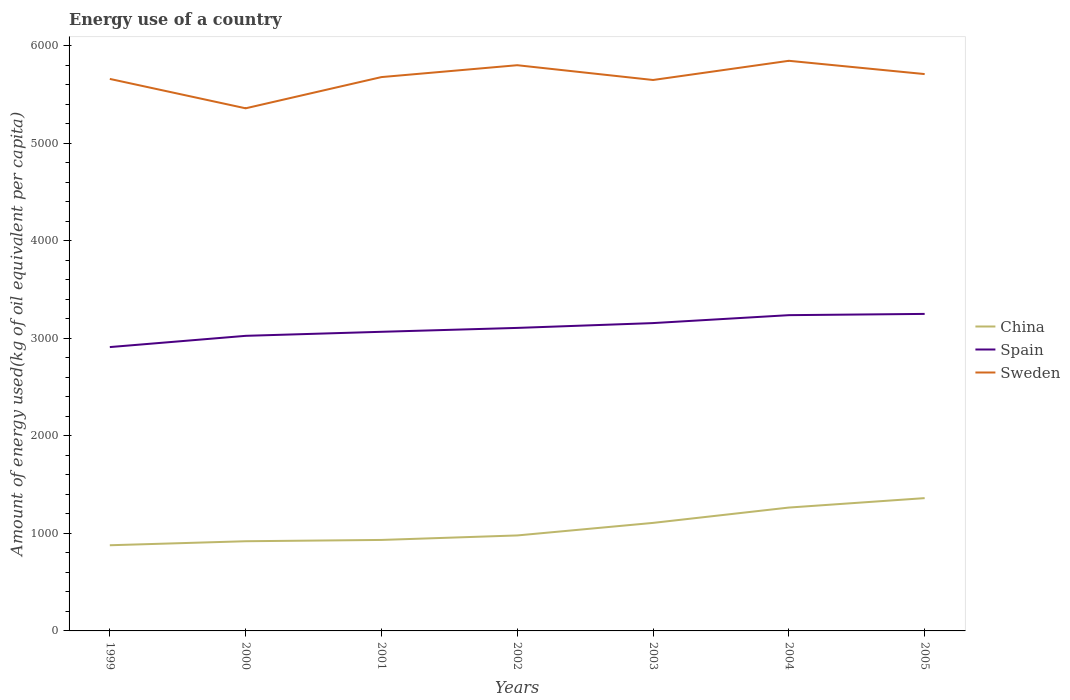How many different coloured lines are there?
Give a very brief answer. 3. Across all years, what is the maximum amount of energy used in in China?
Your answer should be compact. 878.64. What is the total amount of energy used in in Sweden in the graph?
Your answer should be compact. 301.35. What is the difference between the highest and the second highest amount of energy used in in Sweden?
Offer a terse response. 487.2. What is the difference between the highest and the lowest amount of energy used in in Sweden?
Offer a terse response. 4. How many years are there in the graph?
Keep it short and to the point. 7. What is the difference between two consecutive major ticks on the Y-axis?
Provide a short and direct response. 1000. Are the values on the major ticks of Y-axis written in scientific E-notation?
Your answer should be compact. No. How are the legend labels stacked?
Your answer should be compact. Vertical. What is the title of the graph?
Offer a terse response. Energy use of a country. What is the label or title of the X-axis?
Your answer should be very brief. Years. What is the label or title of the Y-axis?
Your answer should be very brief. Amount of energy used(kg of oil equivalent per capita). What is the Amount of energy used(kg of oil equivalent per capita) of China in 1999?
Give a very brief answer. 878.64. What is the Amount of energy used(kg of oil equivalent per capita) of Spain in 1999?
Provide a short and direct response. 2911.18. What is the Amount of energy used(kg of oil equivalent per capita) of Sweden in 1999?
Provide a succinct answer. 5661.49. What is the Amount of energy used(kg of oil equivalent per capita) of China in 2000?
Your response must be concise. 919.78. What is the Amount of energy used(kg of oil equivalent per capita) in Spain in 2000?
Provide a succinct answer. 3026.49. What is the Amount of energy used(kg of oil equivalent per capita) in Sweden in 2000?
Ensure brevity in your answer.  5360.15. What is the Amount of energy used(kg of oil equivalent per capita) of China in 2001?
Your answer should be very brief. 933.13. What is the Amount of energy used(kg of oil equivalent per capita) of Spain in 2001?
Provide a succinct answer. 3067.97. What is the Amount of energy used(kg of oil equivalent per capita) in Sweden in 2001?
Provide a short and direct response. 5680.28. What is the Amount of energy used(kg of oil equivalent per capita) in China in 2002?
Provide a succinct answer. 979.25. What is the Amount of energy used(kg of oil equivalent per capita) in Spain in 2002?
Keep it short and to the point. 3107.87. What is the Amount of energy used(kg of oil equivalent per capita) of Sweden in 2002?
Your response must be concise. 5802.11. What is the Amount of energy used(kg of oil equivalent per capita) in China in 2003?
Provide a succinct answer. 1108.01. What is the Amount of energy used(kg of oil equivalent per capita) in Spain in 2003?
Provide a succinct answer. 3157.23. What is the Amount of energy used(kg of oil equivalent per capita) in Sweden in 2003?
Your answer should be compact. 5650.44. What is the Amount of energy used(kg of oil equivalent per capita) in China in 2004?
Ensure brevity in your answer.  1265.25. What is the Amount of energy used(kg of oil equivalent per capita) in Spain in 2004?
Make the answer very short. 3238.5. What is the Amount of energy used(kg of oil equivalent per capita) of Sweden in 2004?
Ensure brevity in your answer.  5847.34. What is the Amount of energy used(kg of oil equivalent per capita) in China in 2005?
Offer a very short reply. 1362.01. What is the Amount of energy used(kg of oil equivalent per capita) in Spain in 2005?
Give a very brief answer. 3251.4. What is the Amount of energy used(kg of oil equivalent per capita) of Sweden in 2005?
Provide a short and direct response. 5711.13. Across all years, what is the maximum Amount of energy used(kg of oil equivalent per capita) in China?
Your answer should be very brief. 1362.01. Across all years, what is the maximum Amount of energy used(kg of oil equivalent per capita) of Spain?
Offer a terse response. 3251.4. Across all years, what is the maximum Amount of energy used(kg of oil equivalent per capita) in Sweden?
Offer a very short reply. 5847.34. Across all years, what is the minimum Amount of energy used(kg of oil equivalent per capita) of China?
Provide a short and direct response. 878.64. Across all years, what is the minimum Amount of energy used(kg of oil equivalent per capita) in Spain?
Give a very brief answer. 2911.18. Across all years, what is the minimum Amount of energy used(kg of oil equivalent per capita) of Sweden?
Ensure brevity in your answer.  5360.15. What is the total Amount of energy used(kg of oil equivalent per capita) in China in the graph?
Provide a succinct answer. 7446.05. What is the total Amount of energy used(kg of oil equivalent per capita) in Spain in the graph?
Offer a terse response. 2.18e+04. What is the total Amount of energy used(kg of oil equivalent per capita) in Sweden in the graph?
Your answer should be compact. 3.97e+04. What is the difference between the Amount of energy used(kg of oil equivalent per capita) in China in 1999 and that in 2000?
Ensure brevity in your answer.  -41.14. What is the difference between the Amount of energy used(kg of oil equivalent per capita) of Spain in 1999 and that in 2000?
Your response must be concise. -115.31. What is the difference between the Amount of energy used(kg of oil equivalent per capita) of Sweden in 1999 and that in 2000?
Make the answer very short. 301.35. What is the difference between the Amount of energy used(kg of oil equivalent per capita) in China in 1999 and that in 2001?
Offer a terse response. -54.49. What is the difference between the Amount of energy used(kg of oil equivalent per capita) in Spain in 1999 and that in 2001?
Make the answer very short. -156.79. What is the difference between the Amount of energy used(kg of oil equivalent per capita) in Sweden in 1999 and that in 2001?
Your answer should be compact. -18.79. What is the difference between the Amount of energy used(kg of oil equivalent per capita) of China in 1999 and that in 2002?
Keep it short and to the point. -100.61. What is the difference between the Amount of energy used(kg of oil equivalent per capita) in Spain in 1999 and that in 2002?
Give a very brief answer. -196.68. What is the difference between the Amount of energy used(kg of oil equivalent per capita) of Sweden in 1999 and that in 2002?
Offer a very short reply. -140.62. What is the difference between the Amount of energy used(kg of oil equivalent per capita) of China in 1999 and that in 2003?
Give a very brief answer. -229.37. What is the difference between the Amount of energy used(kg of oil equivalent per capita) of Spain in 1999 and that in 2003?
Offer a very short reply. -246.04. What is the difference between the Amount of energy used(kg of oil equivalent per capita) of Sweden in 1999 and that in 2003?
Your response must be concise. 11.05. What is the difference between the Amount of energy used(kg of oil equivalent per capita) of China in 1999 and that in 2004?
Provide a succinct answer. -386.61. What is the difference between the Amount of energy used(kg of oil equivalent per capita) of Spain in 1999 and that in 2004?
Keep it short and to the point. -327.32. What is the difference between the Amount of energy used(kg of oil equivalent per capita) in Sweden in 1999 and that in 2004?
Your answer should be compact. -185.85. What is the difference between the Amount of energy used(kg of oil equivalent per capita) of China in 1999 and that in 2005?
Provide a succinct answer. -483.37. What is the difference between the Amount of energy used(kg of oil equivalent per capita) of Spain in 1999 and that in 2005?
Ensure brevity in your answer.  -340.21. What is the difference between the Amount of energy used(kg of oil equivalent per capita) of Sweden in 1999 and that in 2005?
Make the answer very short. -49.64. What is the difference between the Amount of energy used(kg of oil equivalent per capita) in China in 2000 and that in 2001?
Your response must be concise. -13.35. What is the difference between the Amount of energy used(kg of oil equivalent per capita) in Spain in 2000 and that in 2001?
Your answer should be compact. -41.48. What is the difference between the Amount of energy used(kg of oil equivalent per capita) in Sweden in 2000 and that in 2001?
Ensure brevity in your answer.  -320.14. What is the difference between the Amount of energy used(kg of oil equivalent per capita) of China in 2000 and that in 2002?
Make the answer very short. -59.47. What is the difference between the Amount of energy used(kg of oil equivalent per capita) in Spain in 2000 and that in 2002?
Give a very brief answer. -81.38. What is the difference between the Amount of energy used(kg of oil equivalent per capita) of Sweden in 2000 and that in 2002?
Give a very brief answer. -441.96. What is the difference between the Amount of energy used(kg of oil equivalent per capita) in China in 2000 and that in 2003?
Offer a terse response. -188.23. What is the difference between the Amount of energy used(kg of oil equivalent per capita) of Spain in 2000 and that in 2003?
Provide a short and direct response. -130.74. What is the difference between the Amount of energy used(kg of oil equivalent per capita) in Sweden in 2000 and that in 2003?
Provide a short and direct response. -290.29. What is the difference between the Amount of energy used(kg of oil equivalent per capita) of China in 2000 and that in 2004?
Your answer should be compact. -345.47. What is the difference between the Amount of energy used(kg of oil equivalent per capita) in Spain in 2000 and that in 2004?
Keep it short and to the point. -212.01. What is the difference between the Amount of energy used(kg of oil equivalent per capita) of Sweden in 2000 and that in 2004?
Ensure brevity in your answer.  -487.2. What is the difference between the Amount of energy used(kg of oil equivalent per capita) of China in 2000 and that in 2005?
Your answer should be very brief. -442.23. What is the difference between the Amount of energy used(kg of oil equivalent per capita) in Spain in 2000 and that in 2005?
Make the answer very short. -224.91. What is the difference between the Amount of energy used(kg of oil equivalent per capita) in Sweden in 2000 and that in 2005?
Your response must be concise. -350.98. What is the difference between the Amount of energy used(kg of oil equivalent per capita) in China in 2001 and that in 2002?
Your answer should be compact. -46.12. What is the difference between the Amount of energy used(kg of oil equivalent per capita) of Spain in 2001 and that in 2002?
Offer a terse response. -39.9. What is the difference between the Amount of energy used(kg of oil equivalent per capita) of Sweden in 2001 and that in 2002?
Your answer should be compact. -121.83. What is the difference between the Amount of energy used(kg of oil equivalent per capita) of China in 2001 and that in 2003?
Keep it short and to the point. -174.88. What is the difference between the Amount of energy used(kg of oil equivalent per capita) in Spain in 2001 and that in 2003?
Keep it short and to the point. -89.25. What is the difference between the Amount of energy used(kg of oil equivalent per capita) of Sweden in 2001 and that in 2003?
Provide a succinct answer. 29.84. What is the difference between the Amount of energy used(kg of oil equivalent per capita) in China in 2001 and that in 2004?
Offer a very short reply. -332.12. What is the difference between the Amount of energy used(kg of oil equivalent per capita) in Spain in 2001 and that in 2004?
Give a very brief answer. -170.53. What is the difference between the Amount of energy used(kg of oil equivalent per capita) of Sweden in 2001 and that in 2004?
Provide a short and direct response. -167.06. What is the difference between the Amount of energy used(kg of oil equivalent per capita) in China in 2001 and that in 2005?
Offer a very short reply. -428.88. What is the difference between the Amount of energy used(kg of oil equivalent per capita) in Spain in 2001 and that in 2005?
Ensure brevity in your answer.  -183.42. What is the difference between the Amount of energy used(kg of oil equivalent per capita) in Sweden in 2001 and that in 2005?
Your response must be concise. -30.85. What is the difference between the Amount of energy used(kg of oil equivalent per capita) in China in 2002 and that in 2003?
Ensure brevity in your answer.  -128.76. What is the difference between the Amount of energy used(kg of oil equivalent per capita) of Spain in 2002 and that in 2003?
Make the answer very short. -49.36. What is the difference between the Amount of energy used(kg of oil equivalent per capita) in Sweden in 2002 and that in 2003?
Give a very brief answer. 151.67. What is the difference between the Amount of energy used(kg of oil equivalent per capita) in China in 2002 and that in 2004?
Provide a short and direct response. -286. What is the difference between the Amount of energy used(kg of oil equivalent per capita) of Spain in 2002 and that in 2004?
Provide a succinct answer. -130.64. What is the difference between the Amount of energy used(kg of oil equivalent per capita) of Sweden in 2002 and that in 2004?
Offer a very short reply. -45.23. What is the difference between the Amount of energy used(kg of oil equivalent per capita) of China in 2002 and that in 2005?
Provide a short and direct response. -382.76. What is the difference between the Amount of energy used(kg of oil equivalent per capita) in Spain in 2002 and that in 2005?
Keep it short and to the point. -143.53. What is the difference between the Amount of energy used(kg of oil equivalent per capita) of Sweden in 2002 and that in 2005?
Ensure brevity in your answer.  90.98. What is the difference between the Amount of energy used(kg of oil equivalent per capita) in China in 2003 and that in 2004?
Provide a succinct answer. -157.24. What is the difference between the Amount of energy used(kg of oil equivalent per capita) in Spain in 2003 and that in 2004?
Offer a very short reply. -81.28. What is the difference between the Amount of energy used(kg of oil equivalent per capita) of Sweden in 2003 and that in 2004?
Provide a short and direct response. -196.91. What is the difference between the Amount of energy used(kg of oil equivalent per capita) in China in 2003 and that in 2005?
Provide a short and direct response. -254. What is the difference between the Amount of energy used(kg of oil equivalent per capita) of Spain in 2003 and that in 2005?
Make the answer very short. -94.17. What is the difference between the Amount of energy used(kg of oil equivalent per capita) in Sweden in 2003 and that in 2005?
Offer a very short reply. -60.69. What is the difference between the Amount of energy used(kg of oil equivalent per capita) of China in 2004 and that in 2005?
Provide a short and direct response. -96.76. What is the difference between the Amount of energy used(kg of oil equivalent per capita) in Spain in 2004 and that in 2005?
Your answer should be compact. -12.89. What is the difference between the Amount of energy used(kg of oil equivalent per capita) in Sweden in 2004 and that in 2005?
Provide a succinct answer. 136.22. What is the difference between the Amount of energy used(kg of oil equivalent per capita) of China in 1999 and the Amount of energy used(kg of oil equivalent per capita) of Spain in 2000?
Offer a very short reply. -2147.85. What is the difference between the Amount of energy used(kg of oil equivalent per capita) in China in 1999 and the Amount of energy used(kg of oil equivalent per capita) in Sweden in 2000?
Provide a succinct answer. -4481.51. What is the difference between the Amount of energy used(kg of oil equivalent per capita) in Spain in 1999 and the Amount of energy used(kg of oil equivalent per capita) in Sweden in 2000?
Ensure brevity in your answer.  -2448.96. What is the difference between the Amount of energy used(kg of oil equivalent per capita) in China in 1999 and the Amount of energy used(kg of oil equivalent per capita) in Spain in 2001?
Your answer should be very brief. -2189.33. What is the difference between the Amount of energy used(kg of oil equivalent per capita) in China in 1999 and the Amount of energy used(kg of oil equivalent per capita) in Sweden in 2001?
Give a very brief answer. -4801.64. What is the difference between the Amount of energy used(kg of oil equivalent per capita) of Spain in 1999 and the Amount of energy used(kg of oil equivalent per capita) of Sweden in 2001?
Your answer should be very brief. -2769.1. What is the difference between the Amount of energy used(kg of oil equivalent per capita) of China in 1999 and the Amount of energy used(kg of oil equivalent per capita) of Spain in 2002?
Make the answer very short. -2229.23. What is the difference between the Amount of energy used(kg of oil equivalent per capita) in China in 1999 and the Amount of energy used(kg of oil equivalent per capita) in Sweden in 2002?
Make the answer very short. -4923.47. What is the difference between the Amount of energy used(kg of oil equivalent per capita) of Spain in 1999 and the Amount of energy used(kg of oil equivalent per capita) of Sweden in 2002?
Provide a short and direct response. -2890.93. What is the difference between the Amount of energy used(kg of oil equivalent per capita) of China in 1999 and the Amount of energy used(kg of oil equivalent per capita) of Spain in 2003?
Give a very brief answer. -2278.59. What is the difference between the Amount of energy used(kg of oil equivalent per capita) of China in 1999 and the Amount of energy used(kg of oil equivalent per capita) of Sweden in 2003?
Keep it short and to the point. -4771.8. What is the difference between the Amount of energy used(kg of oil equivalent per capita) of Spain in 1999 and the Amount of energy used(kg of oil equivalent per capita) of Sweden in 2003?
Ensure brevity in your answer.  -2739.25. What is the difference between the Amount of energy used(kg of oil equivalent per capita) in China in 1999 and the Amount of energy used(kg of oil equivalent per capita) in Spain in 2004?
Offer a very short reply. -2359.86. What is the difference between the Amount of energy used(kg of oil equivalent per capita) of China in 1999 and the Amount of energy used(kg of oil equivalent per capita) of Sweden in 2004?
Give a very brief answer. -4968.71. What is the difference between the Amount of energy used(kg of oil equivalent per capita) of Spain in 1999 and the Amount of energy used(kg of oil equivalent per capita) of Sweden in 2004?
Provide a succinct answer. -2936.16. What is the difference between the Amount of energy used(kg of oil equivalent per capita) in China in 1999 and the Amount of energy used(kg of oil equivalent per capita) in Spain in 2005?
Make the answer very short. -2372.76. What is the difference between the Amount of energy used(kg of oil equivalent per capita) in China in 1999 and the Amount of energy used(kg of oil equivalent per capita) in Sweden in 2005?
Ensure brevity in your answer.  -4832.49. What is the difference between the Amount of energy used(kg of oil equivalent per capita) of Spain in 1999 and the Amount of energy used(kg of oil equivalent per capita) of Sweden in 2005?
Provide a succinct answer. -2799.94. What is the difference between the Amount of energy used(kg of oil equivalent per capita) of China in 2000 and the Amount of energy used(kg of oil equivalent per capita) of Spain in 2001?
Your response must be concise. -2148.19. What is the difference between the Amount of energy used(kg of oil equivalent per capita) of China in 2000 and the Amount of energy used(kg of oil equivalent per capita) of Sweden in 2001?
Give a very brief answer. -4760.5. What is the difference between the Amount of energy used(kg of oil equivalent per capita) in Spain in 2000 and the Amount of energy used(kg of oil equivalent per capita) in Sweden in 2001?
Give a very brief answer. -2653.79. What is the difference between the Amount of energy used(kg of oil equivalent per capita) of China in 2000 and the Amount of energy used(kg of oil equivalent per capita) of Spain in 2002?
Provide a succinct answer. -2188.09. What is the difference between the Amount of energy used(kg of oil equivalent per capita) of China in 2000 and the Amount of energy used(kg of oil equivalent per capita) of Sweden in 2002?
Your response must be concise. -4882.33. What is the difference between the Amount of energy used(kg of oil equivalent per capita) in Spain in 2000 and the Amount of energy used(kg of oil equivalent per capita) in Sweden in 2002?
Offer a very short reply. -2775.62. What is the difference between the Amount of energy used(kg of oil equivalent per capita) in China in 2000 and the Amount of energy used(kg of oil equivalent per capita) in Spain in 2003?
Provide a short and direct response. -2237.45. What is the difference between the Amount of energy used(kg of oil equivalent per capita) in China in 2000 and the Amount of energy used(kg of oil equivalent per capita) in Sweden in 2003?
Provide a short and direct response. -4730.66. What is the difference between the Amount of energy used(kg of oil equivalent per capita) in Spain in 2000 and the Amount of energy used(kg of oil equivalent per capita) in Sweden in 2003?
Give a very brief answer. -2623.95. What is the difference between the Amount of energy used(kg of oil equivalent per capita) of China in 2000 and the Amount of energy used(kg of oil equivalent per capita) of Spain in 2004?
Offer a terse response. -2318.72. What is the difference between the Amount of energy used(kg of oil equivalent per capita) in China in 2000 and the Amount of energy used(kg of oil equivalent per capita) in Sweden in 2004?
Offer a terse response. -4927.57. What is the difference between the Amount of energy used(kg of oil equivalent per capita) in Spain in 2000 and the Amount of energy used(kg of oil equivalent per capita) in Sweden in 2004?
Offer a terse response. -2820.85. What is the difference between the Amount of energy used(kg of oil equivalent per capita) of China in 2000 and the Amount of energy used(kg of oil equivalent per capita) of Spain in 2005?
Make the answer very short. -2331.62. What is the difference between the Amount of energy used(kg of oil equivalent per capita) in China in 2000 and the Amount of energy used(kg of oil equivalent per capita) in Sweden in 2005?
Provide a short and direct response. -4791.35. What is the difference between the Amount of energy used(kg of oil equivalent per capita) of Spain in 2000 and the Amount of energy used(kg of oil equivalent per capita) of Sweden in 2005?
Ensure brevity in your answer.  -2684.64. What is the difference between the Amount of energy used(kg of oil equivalent per capita) of China in 2001 and the Amount of energy used(kg of oil equivalent per capita) of Spain in 2002?
Offer a very short reply. -2174.74. What is the difference between the Amount of energy used(kg of oil equivalent per capita) in China in 2001 and the Amount of energy used(kg of oil equivalent per capita) in Sweden in 2002?
Keep it short and to the point. -4868.98. What is the difference between the Amount of energy used(kg of oil equivalent per capita) in Spain in 2001 and the Amount of energy used(kg of oil equivalent per capita) in Sweden in 2002?
Ensure brevity in your answer.  -2734.14. What is the difference between the Amount of energy used(kg of oil equivalent per capita) of China in 2001 and the Amount of energy used(kg of oil equivalent per capita) of Spain in 2003?
Make the answer very short. -2224.1. What is the difference between the Amount of energy used(kg of oil equivalent per capita) in China in 2001 and the Amount of energy used(kg of oil equivalent per capita) in Sweden in 2003?
Offer a very short reply. -4717.31. What is the difference between the Amount of energy used(kg of oil equivalent per capita) of Spain in 2001 and the Amount of energy used(kg of oil equivalent per capita) of Sweden in 2003?
Your response must be concise. -2582.47. What is the difference between the Amount of energy used(kg of oil equivalent per capita) of China in 2001 and the Amount of energy used(kg of oil equivalent per capita) of Spain in 2004?
Offer a very short reply. -2305.38. What is the difference between the Amount of energy used(kg of oil equivalent per capita) in China in 2001 and the Amount of energy used(kg of oil equivalent per capita) in Sweden in 2004?
Provide a short and direct response. -4914.22. What is the difference between the Amount of energy used(kg of oil equivalent per capita) of Spain in 2001 and the Amount of energy used(kg of oil equivalent per capita) of Sweden in 2004?
Ensure brevity in your answer.  -2779.37. What is the difference between the Amount of energy used(kg of oil equivalent per capita) in China in 2001 and the Amount of energy used(kg of oil equivalent per capita) in Spain in 2005?
Your response must be concise. -2318.27. What is the difference between the Amount of energy used(kg of oil equivalent per capita) in China in 2001 and the Amount of energy used(kg of oil equivalent per capita) in Sweden in 2005?
Your answer should be compact. -4778. What is the difference between the Amount of energy used(kg of oil equivalent per capita) in Spain in 2001 and the Amount of energy used(kg of oil equivalent per capita) in Sweden in 2005?
Offer a terse response. -2643.16. What is the difference between the Amount of energy used(kg of oil equivalent per capita) of China in 2002 and the Amount of energy used(kg of oil equivalent per capita) of Spain in 2003?
Your answer should be compact. -2177.98. What is the difference between the Amount of energy used(kg of oil equivalent per capita) of China in 2002 and the Amount of energy used(kg of oil equivalent per capita) of Sweden in 2003?
Keep it short and to the point. -4671.19. What is the difference between the Amount of energy used(kg of oil equivalent per capita) of Spain in 2002 and the Amount of energy used(kg of oil equivalent per capita) of Sweden in 2003?
Your response must be concise. -2542.57. What is the difference between the Amount of energy used(kg of oil equivalent per capita) of China in 2002 and the Amount of energy used(kg of oil equivalent per capita) of Spain in 2004?
Your answer should be very brief. -2259.25. What is the difference between the Amount of energy used(kg of oil equivalent per capita) in China in 2002 and the Amount of energy used(kg of oil equivalent per capita) in Sweden in 2004?
Provide a succinct answer. -4868.09. What is the difference between the Amount of energy used(kg of oil equivalent per capita) of Spain in 2002 and the Amount of energy used(kg of oil equivalent per capita) of Sweden in 2004?
Provide a short and direct response. -2739.48. What is the difference between the Amount of energy used(kg of oil equivalent per capita) of China in 2002 and the Amount of energy used(kg of oil equivalent per capita) of Spain in 2005?
Your response must be concise. -2272.15. What is the difference between the Amount of energy used(kg of oil equivalent per capita) of China in 2002 and the Amount of energy used(kg of oil equivalent per capita) of Sweden in 2005?
Offer a very short reply. -4731.88. What is the difference between the Amount of energy used(kg of oil equivalent per capita) in Spain in 2002 and the Amount of energy used(kg of oil equivalent per capita) in Sweden in 2005?
Your answer should be compact. -2603.26. What is the difference between the Amount of energy used(kg of oil equivalent per capita) of China in 2003 and the Amount of energy used(kg of oil equivalent per capita) of Spain in 2004?
Offer a very short reply. -2130.5. What is the difference between the Amount of energy used(kg of oil equivalent per capita) of China in 2003 and the Amount of energy used(kg of oil equivalent per capita) of Sweden in 2004?
Your answer should be compact. -4739.34. What is the difference between the Amount of energy used(kg of oil equivalent per capita) in Spain in 2003 and the Amount of energy used(kg of oil equivalent per capita) in Sweden in 2004?
Make the answer very short. -2690.12. What is the difference between the Amount of energy used(kg of oil equivalent per capita) of China in 2003 and the Amount of energy used(kg of oil equivalent per capita) of Spain in 2005?
Ensure brevity in your answer.  -2143.39. What is the difference between the Amount of energy used(kg of oil equivalent per capita) in China in 2003 and the Amount of energy used(kg of oil equivalent per capita) in Sweden in 2005?
Your answer should be compact. -4603.12. What is the difference between the Amount of energy used(kg of oil equivalent per capita) of Spain in 2003 and the Amount of energy used(kg of oil equivalent per capita) of Sweden in 2005?
Your answer should be compact. -2553.9. What is the difference between the Amount of energy used(kg of oil equivalent per capita) of China in 2004 and the Amount of energy used(kg of oil equivalent per capita) of Spain in 2005?
Your answer should be very brief. -1986.15. What is the difference between the Amount of energy used(kg of oil equivalent per capita) of China in 2004 and the Amount of energy used(kg of oil equivalent per capita) of Sweden in 2005?
Your answer should be compact. -4445.88. What is the difference between the Amount of energy used(kg of oil equivalent per capita) in Spain in 2004 and the Amount of energy used(kg of oil equivalent per capita) in Sweden in 2005?
Make the answer very short. -2472.62. What is the average Amount of energy used(kg of oil equivalent per capita) of China per year?
Provide a succinct answer. 1063.72. What is the average Amount of energy used(kg of oil equivalent per capita) of Spain per year?
Your answer should be compact. 3108.66. What is the average Amount of energy used(kg of oil equivalent per capita) in Sweden per year?
Provide a short and direct response. 5673.28. In the year 1999, what is the difference between the Amount of energy used(kg of oil equivalent per capita) of China and Amount of energy used(kg of oil equivalent per capita) of Spain?
Keep it short and to the point. -2032.55. In the year 1999, what is the difference between the Amount of energy used(kg of oil equivalent per capita) of China and Amount of energy used(kg of oil equivalent per capita) of Sweden?
Make the answer very short. -4782.85. In the year 1999, what is the difference between the Amount of energy used(kg of oil equivalent per capita) of Spain and Amount of energy used(kg of oil equivalent per capita) of Sweden?
Make the answer very short. -2750.31. In the year 2000, what is the difference between the Amount of energy used(kg of oil equivalent per capita) in China and Amount of energy used(kg of oil equivalent per capita) in Spain?
Ensure brevity in your answer.  -2106.71. In the year 2000, what is the difference between the Amount of energy used(kg of oil equivalent per capita) of China and Amount of energy used(kg of oil equivalent per capita) of Sweden?
Make the answer very short. -4440.37. In the year 2000, what is the difference between the Amount of energy used(kg of oil equivalent per capita) of Spain and Amount of energy used(kg of oil equivalent per capita) of Sweden?
Your answer should be compact. -2333.66. In the year 2001, what is the difference between the Amount of energy used(kg of oil equivalent per capita) in China and Amount of energy used(kg of oil equivalent per capita) in Spain?
Your answer should be compact. -2134.85. In the year 2001, what is the difference between the Amount of energy used(kg of oil equivalent per capita) of China and Amount of energy used(kg of oil equivalent per capita) of Sweden?
Your answer should be compact. -4747.15. In the year 2001, what is the difference between the Amount of energy used(kg of oil equivalent per capita) of Spain and Amount of energy used(kg of oil equivalent per capita) of Sweden?
Ensure brevity in your answer.  -2612.31. In the year 2002, what is the difference between the Amount of energy used(kg of oil equivalent per capita) in China and Amount of energy used(kg of oil equivalent per capita) in Spain?
Give a very brief answer. -2128.62. In the year 2002, what is the difference between the Amount of energy used(kg of oil equivalent per capita) in China and Amount of energy used(kg of oil equivalent per capita) in Sweden?
Your answer should be very brief. -4822.86. In the year 2002, what is the difference between the Amount of energy used(kg of oil equivalent per capita) of Spain and Amount of energy used(kg of oil equivalent per capita) of Sweden?
Offer a terse response. -2694.24. In the year 2003, what is the difference between the Amount of energy used(kg of oil equivalent per capita) in China and Amount of energy used(kg of oil equivalent per capita) in Spain?
Make the answer very short. -2049.22. In the year 2003, what is the difference between the Amount of energy used(kg of oil equivalent per capita) in China and Amount of energy used(kg of oil equivalent per capita) in Sweden?
Provide a short and direct response. -4542.43. In the year 2003, what is the difference between the Amount of energy used(kg of oil equivalent per capita) of Spain and Amount of energy used(kg of oil equivalent per capita) of Sweden?
Your answer should be very brief. -2493.21. In the year 2004, what is the difference between the Amount of energy used(kg of oil equivalent per capita) of China and Amount of energy used(kg of oil equivalent per capita) of Spain?
Provide a succinct answer. -1973.26. In the year 2004, what is the difference between the Amount of energy used(kg of oil equivalent per capita) of China and Amount of energy used(kg of oil equivalent per capita) of Sweden?
Provide a short and direct response. -4582.1. In the year 2004, what is the difference between the Amount of energy used(kg of oil equivalent per capita) of Spain and Amount of energy used(kg of oil equivalent per capita) of Sweden?
Keep it short and to the point. -2608.84. In the year 2005, what is the difference between the Amount of energy used(kg of oil equivalent per capita) of China and Amount of energy used(kg of oil equivalent per capita) of Spain?
Provide a succinct answer. -1889.39. In the year 2005, what is the difference between the Amount of energy used(kg of oil equivalent per capita) in China and Amount of energy used(kg of oil equivalent per capita) in Sweden?
Offer a very short reply. -4349.12. In the year 2005, what is the difference between the Amount of energy used(kg of oil equivalent per capita) in Spain and Amount of energy used(kg of oil equivalent per capita) in Sweden?
Provide a succinct answer. -2459.73. What is the ratio of the Amount of energy used(kg of oil equivalent per capita) of China in 1999 to that in 2000?
Provide a short and direct response. 0.96. What is the ratio of the Amount of energy used(kg of oil equivalent per capita) in Spain in 1999 to that in 2000?
Ensure brevity in your answer.  0.96. What is the ratio of the Amount of energy used(kg of oil equivalent per capita) in Sweden in 1999 to that in 2000?
Provide a short and direct response. 1.06. What is the ratio of the Amount of energy used(kg of oil equivalent per capita) of China in 1999 to that in 2001?
Offer a very short reply. 0.94. What is the ratio of the Amount of energy used(kg of oil equivalent per capita) of Spain in 1999 to that in 2001?
Offer a terse response. 0.95. What is the ratio of the Amount of energy used(kg of oil equivalent per capita) of Sweden in 1999 to that in 2001?
Make the answer very short. 1. What is the ratio of the Amount of energy used(kg of oil equivalent per capita) in China in 1999 to that in 2002?
Your response must be concise. 0.9. What is the ratio of the Amount of energy used(kg of oil equivalent per capita) in Spain in 1999 to that in 2002?
Offer a very short reply. 0.94. What is the ratio of the Amount of energy used(kg of oil equivalent per capita) in Sweden in 1999 to that in 2002?
Ensure brevity in your answer.  0.98. What is the ratio of the Amount of energy used(kg of oil equivalent per capita) of China in 1999 to that in 2003?
Provide a succinct answer. 0.79. What is the ratio of the Amount of energy used(kg of oil equivalent per capita) of Spain in 1999 to that in 2003?
Your answer should be very brief. 0.92. What is the ratio of the Amount of energy used(kg of oil equivalent per capita) of Sweden in 1999 to that in 2003?
Ensure brevity in your answer.  1. What is the ratio of the Amount of energy used(kg of oil equivalent per capita) of China in 1999 to that in 2004?
Offer a very short reply. 0.69. What is the ratio of the Amount of energy used(kg of oil equivalent per capita) in Spain in 1999 to that in 2004?
Keep it short and to the point. 0.9. What is the ratio of the Amount of energy used(kg of oil equivalent per capita) of Sweden in 1999 to that in 2004?
Provide a short and direct response. 0.97. What is the ratio of the Amount of energy used(kg of oil equivalent per capita) of China in 1999 to that in 2005?
Make the answer very short. 0.65. What is the ratio of the Amount of energy used(kg of oil equivalent per capita) in Spain in 1999 to that in 2005?
Your response must be concise. 0.9. What is the ratio of the Amount of energy used(kg of oil equivalent per capita) in Sweden in 1999 to that in 2005?
Give a very brief answer. 0.99. What is the ratio of the Amount of energy used(kg of oil equivalent per capita) in China in 2000 to that in 2001?
Your answer should be very brief. 0.99. What is the ratio of the Amount of energy used(kg of oil equivalent per capita) in Spain in 2000 to that in 2001?
Your answer should be compact. 0.99. What is the ratio of the Amount of energy used(kg of oil equivalent per capita) of Sweden in 2000 to that in 2001?
Your response must be concise. 0.94. What is the ratio of the Amount of energy used(kg of oil equivalent per capita) in China in 2000 to that in 2002?
Your answer should be compact. 0.94. What is the ratio of the Amount of energy used(kg of oil equivalent per capita) in Spain in 2000 to that in 2002?
Your response must be concise. 0.97. What is the ratio of the Amount of energy used(kg of oil equivalent per capita) of Sweden in 2000 to that in 2002?
Provide a short and direct response. 0.92. What is the ratio of the Amount of energy used(kg of oil equivalent per capita) in China in 2000 to that in 2003?
Keep it short and to the point. 0.83. What is the ratio of the Amount of energy used(kg of oil equivalent per capita) in Spain in 2000 to that in 2003?
Ensure brevity in your answer.  0.96. What is the ratio of the Amount of energy used(kg of oil equivalent per capita) of Sweden in 2000 to that in 2003?
Offer a terse response. 0.95. What is the ratio of the Amount of energy used(kg of oil equivalent per capita) of China in 2000 to that in 2004?
Ensure brevity in your answer.  0.73. What is the ratio of the Amount of energy used(kg of oil equivalent per capita) in Spain in 2000 to that in 2004?
Give a very brief answer. 0.93. What is the ratio of the Amount of energy used(kg of oil equivalent per capita) in China in 2000 to that in 2005?
Provide a succinct answer. 0.68. What is the ratio of the Amount of energy used(kg of oil equivalent per capita) in Spain in 2000 to that in 2005?
Give a very brief answer. 0.93. What is the ratio of the Amount of energy used(kg of oil equivalent per capita) of Sweden in 2000 to that in 2005?
Your response must be concise. 0.94. What is the ratio of the Amount of energy used(kg of oil equivalent per capita) in China in 2001 to that in 2002?
Your answer should be compact. 0.95. What is the ratio of the Amount of energy used(kg of oil equivalent per capita) of Spain in 2001 to that in 2002?
Make the answer very short. 0.99. What is the ratio of the Amount of energy used(kg of oil equivalent per capita) in China in 2001 to that in 2003?
Offer a terse response. 0.84. What is the ratio of the Amount of energy used(kg of oil equivalent per capita) in Spain in 2001 to that in 2003?
Offer a very short reply. 0.97. What is the ratio of the Amount of energy used(kg of oil equivalent per capita) of China in 2001 to that in 2004?
Provide a short and direct response. 0.74. What is the ratio of the Amount of energy used(kg of oil equivalent per capita) of Spain in 2001 to that in 2004?
Provide a short and direct response. 0.95. What is the ratio of the Amount of energy used(kg of oil equivalent per capita) of Sweden in 2001 to that in 2004?
Your answer should be very brief. 0.97. What is the ratio of the Amount of energy used(kg of oil equivalent per capita) of China in 2001 to that in 2005?
Your answer should be very brief. 0.69. What is the ratio of the Amount of energy used(kg of oil equivalent per capita) in Spain in 2001 to that in 2005?
Make the answer very short. 0.94. What is the ratio of the Amount of energy used(kg of oil equivalent per capita) of Sweden in 2001 to that in 2005?
Ensure brevity in your answer.  0.99. What is the ratio of the Amount of energy used(kg of oil equivalent per capita) of China in 2002 to that in 2003?
Provide a succinct answer. 0.88. What is the ratio of the Amount of energy used(kg of oil equivalent per capita) in Spain in 2002 to that in 2003?
Make the answer very short. 0.98. What is the ratio of the Amount of energy used(kg of oil equivalent per capita) in Sweden in 2002 to that in 2003?
Offer a terse response. 1.03. What is the ratio of the Amount of energy used(kg of oil equivalent per capita) in China in 2002 to that in 2004?
Keep it short and to the point. 0.77. What is the ratio of the Amount of energy used(kg of oil equivalent per capita) in Spain in 2002 to that in 2004?
Make the answer very short. 0.96. What is the ratio of the Amount of energy used(kg of oil equivalent per capita) in China in 2002 to that in 2005?
Your response must be concise. 0.72. What is the ratio of the Amount of energy used(kg of oil equivalent per capita) in Spain in 2002 to that in 2005?
Offer a terse response. 0.96. What is the ratio of the Amount of energy used(kg of oil equivalent per capita) in Sweden in 2002 to that in 2005?
Keep it short and to the point. 1.02. What is the ratio of the Amount of energy used(kg of oil equivalent per capita) of China in 2003 to that in 2004?
Offer a very short reply. 0.88. What is the ratio of the Amount of energy used(kg of oil equivalent per capita) in Spain in 2003 to that in 2004?
Provide a succinct answer. 0.97. What is the ratio of the Amount of energy used(kg of oil equivalent per capita) of Sweden in 2003 to that in 2004?
Offer a terse response. 0.97. What is the ratio of the Amount of energy used(kg of oil equivalent per capita) in China in 2003 to that in 2005?
Your answer should be compact. 0.81. What is the ratio of the Amount of energy used(kg of oil equivalent per capita) in Sweden in 2003 to that in 2005?
Ensure brevity in your answer.  0.99. What is the ratio of the Amount of energy used(kg of oil equivalent per capita) of China in 2004 to that in 2005?
Your response must be concise. 0.93. What is the ratio of the Amount of energy used(kg of oil equivalent per capita) in Spain in 2004 to that in 2005?
Keep it short and to the point. 1. What is the ratio of the Amount of energy used(kg of oil equivalent per capita) in Sweden in 2004 to that in 2005?
Your answer should be compact. 1.02. What is the difference between the highest and the second highest Amount of energy used(kg of oil equivalent per capita) in China?
Ensure brevity in your answer.  96.76. What is the difference between the highest and the second highest Amount of energy used(kg of oil equivalent per capita) of Spain?
Provide a short and direct response. 12.89. What is the difference between the highest and the second highest Amount of energy used(kg of oil equivalent per capita) in Sweden?
Offer a terse response. 45.23. What is the difference between the highest and the lowest Amount of energy used(kg of oil equivalent per capita) of China?
Give a very brief answer. 483.37. What is the difference between the highest and the lowest Amount of energy used(kg of oil equivalent per capita) in Spain?
Your response must be concise. 340.21. What is the difference between the highest and the lowest Amount of energy used(kg of oil equivalent per capita) in Sweden?
Provide a succinct answer. 487.2. 